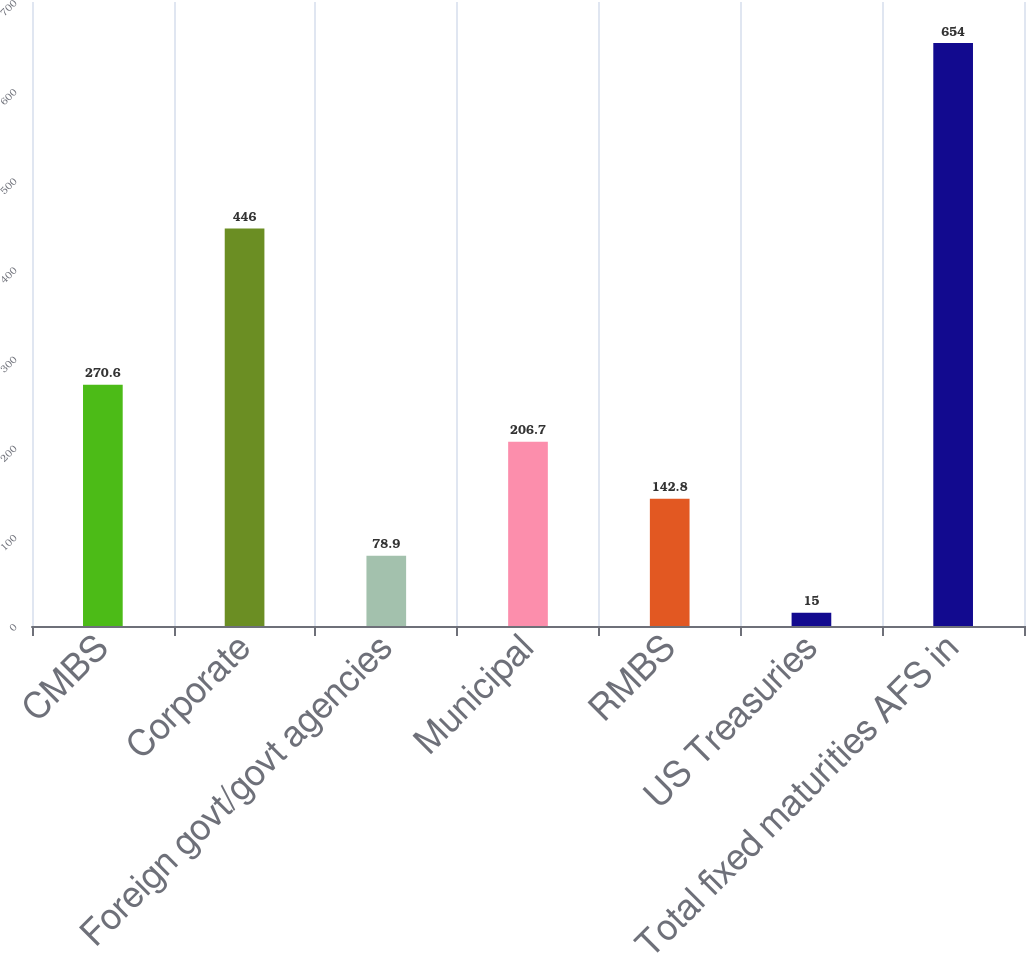Convert chart to OTSL. <chart><loc_0><loc_0><loc_500><loc_500><bar_chart><fcel>CMBS<fcel>Corporate<fcel>Foreign govt/govt agencies<fcel>Municipal<fcel>RMBS<fcel>US Treasuries<fcel>Total fixed maturities AFS in<nl><fcel>270.6<fcel>446<fcel>78.9<fcel>206.7<fcel>142.8<fcel>15<fcel>654<nl></chart> 